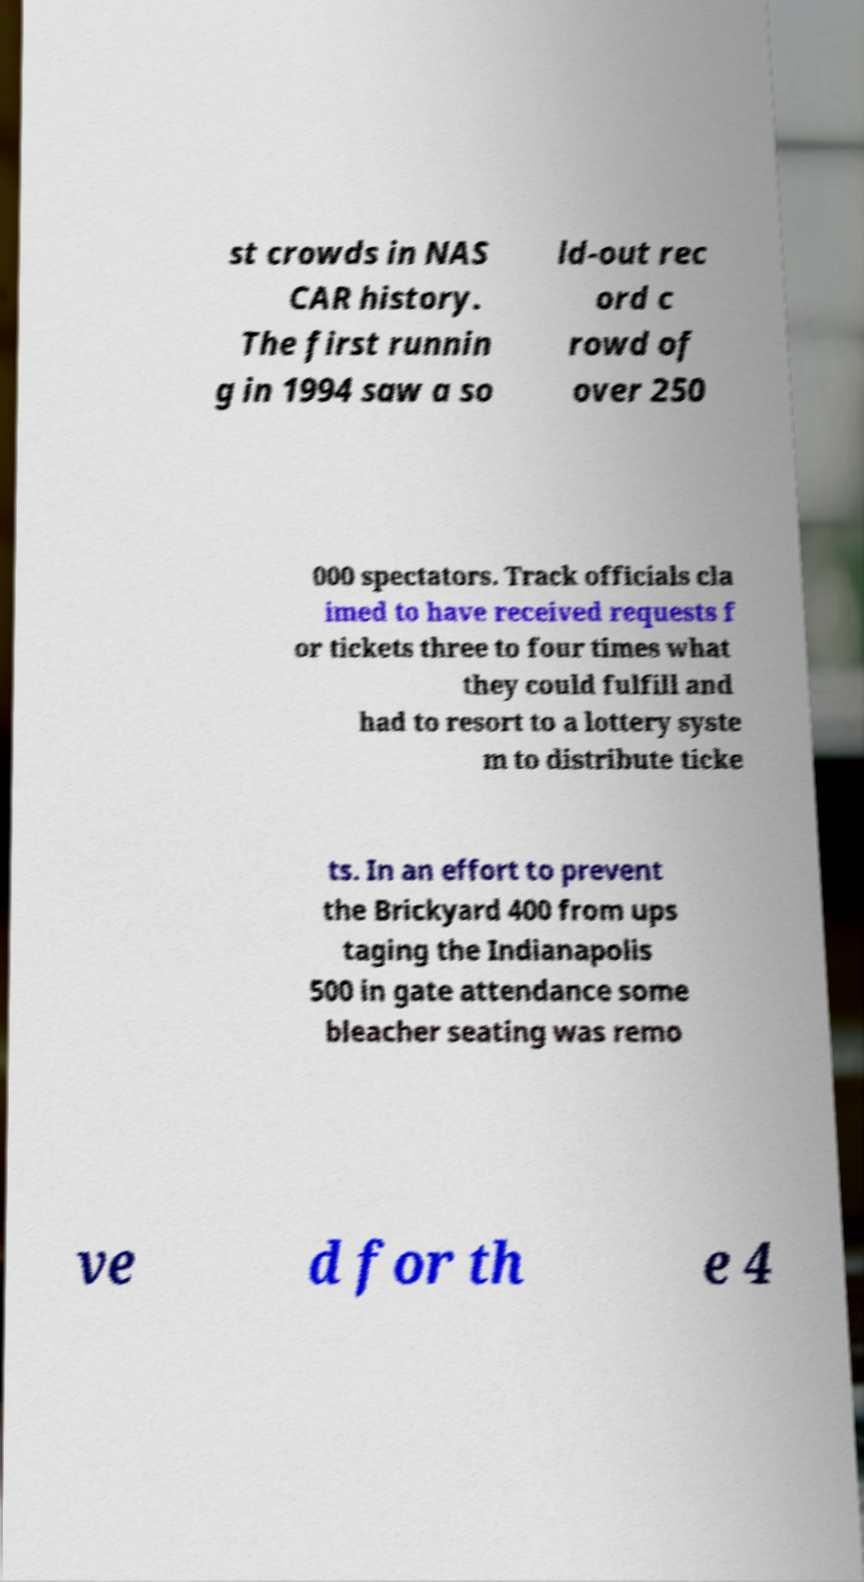There's text embedded in this image that I need extracted. Can you transcribe it verbatim? st crowds in NAS CAR history. The first runnin g in 1994 saw a so ld-out rec ord c rowd of over 250 000 spectators. Track officials cla imed to have received requests f or tickets three to four times what they could fulfill and had to resort to a lottery syste m to distribute ticke ts. In an effort to prevent the Brickyard 400 from ups taging the Indianapolis 500 in gate attendance some bleacher seating was remo ve d for th e 4 